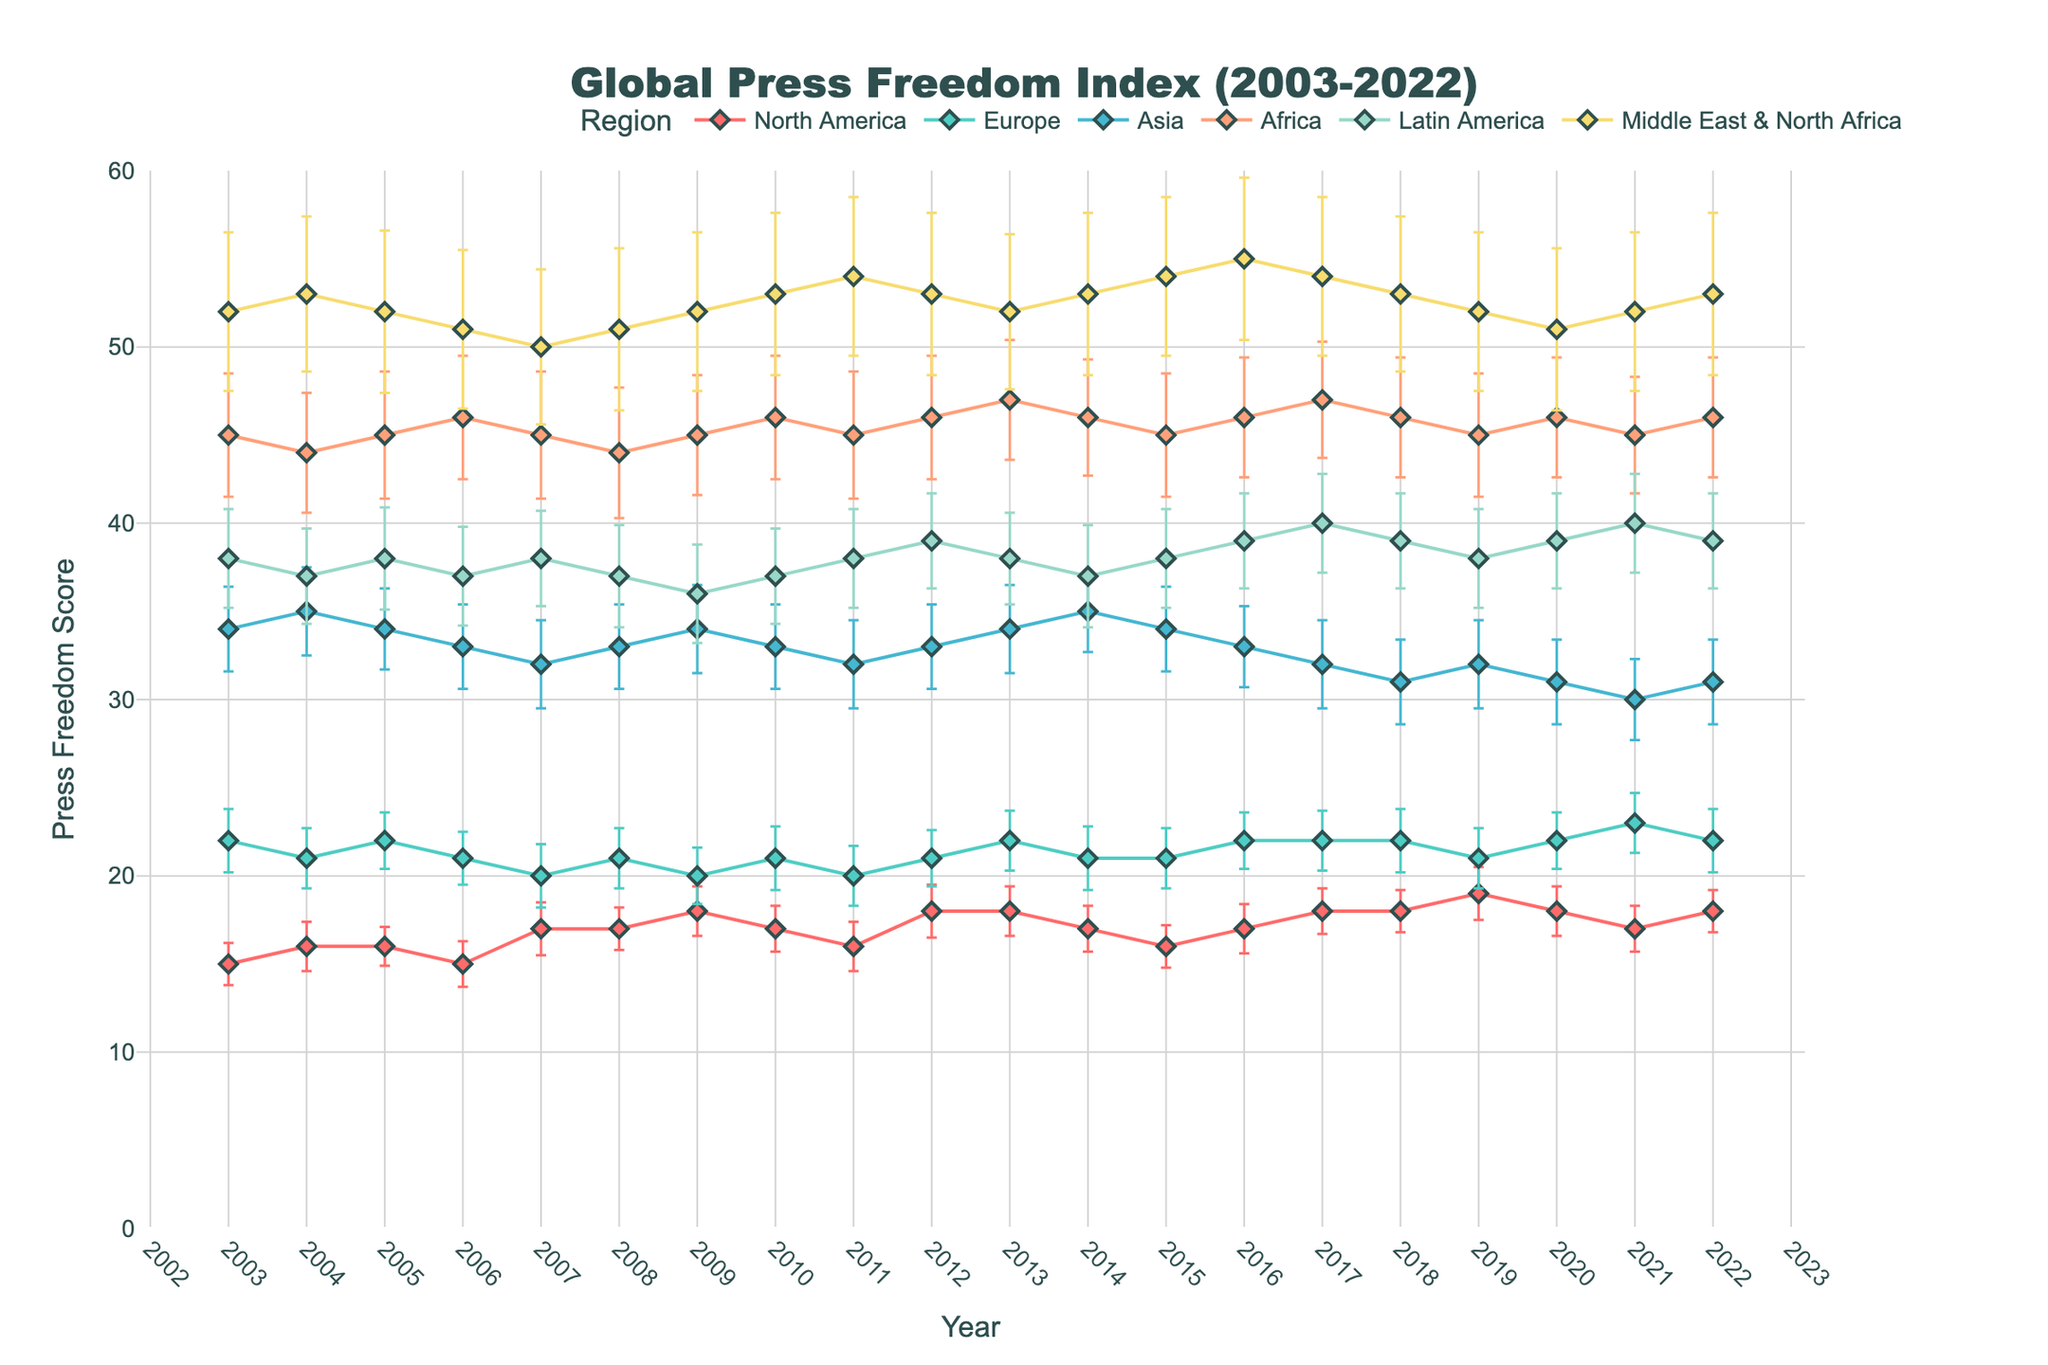What does the title of the figure indicate? The title of the figure directly provides the overall subject and time frame.
Answer: Global Press Freedom Index (2003-2022) Which region has the lowest Press Freedom Score on average across the years? By visually observing the lines, the Middle East & North Africa has the highest scores, indicating it performs poorly in press freedom, making it the lowest scorer overall.
Answer: Middle East & North Africa What year did Europe achieve its highest average Press Freedom Score? By examining the line for Europe, its highest value appears in 2021 with a score of 23.
Answer: 2021 How did the Press Freedom Score for Latin America change from 2003 to 2022? Starting at a score of 38 in 2003, the line for Latin America shows that it fluctuates slightly but ends at a score of 39 in 2022.
Answer: Increased by 1 point (from 38 to 39) Which regions have experienced a downward trend in their Press Freedom Scores? By observing the slopes of the lines, Asia shows a clear downward trend with scores decreasing over the years.
Answer: Asia Compare the Press Freedom Scores of North America and Europe in 2015. Which region had a better score? North America's score for 2015 is 16, and Europe's is 21. Lower scores indicate better press freedom. Therefore, North America had a better score.
Answer: North America What was the standard deviation of the Press Freedom Score for Africa in 2006? The standard deviation for Africa in 2006 is mentioned directly in the data, which is 3.5.
Answer: 3.5 Is there any year where Africa and Latin America had the same Press Freedom Score? Checking the scores year by year shows that in 2008, both Africa and Latin America had a score of 44 and 37 respectively, so there is no matching year.
Answer: No How does the error bar length for Asia compare to that of Europe around the year 2020? The error bars for Asia (length 2.4) are longer than those of Europe (length 1.6-1.8) indicating higher variability in Asia's scores.
Answer: Longer Which year did North America have its highest variability in Press Freedom Scores within these two decades? Observing the error bars, North America's highest variability is indicated by the longest error bar, which is in 2019 with a standard deviation of 1.5.
Answer: 2019 